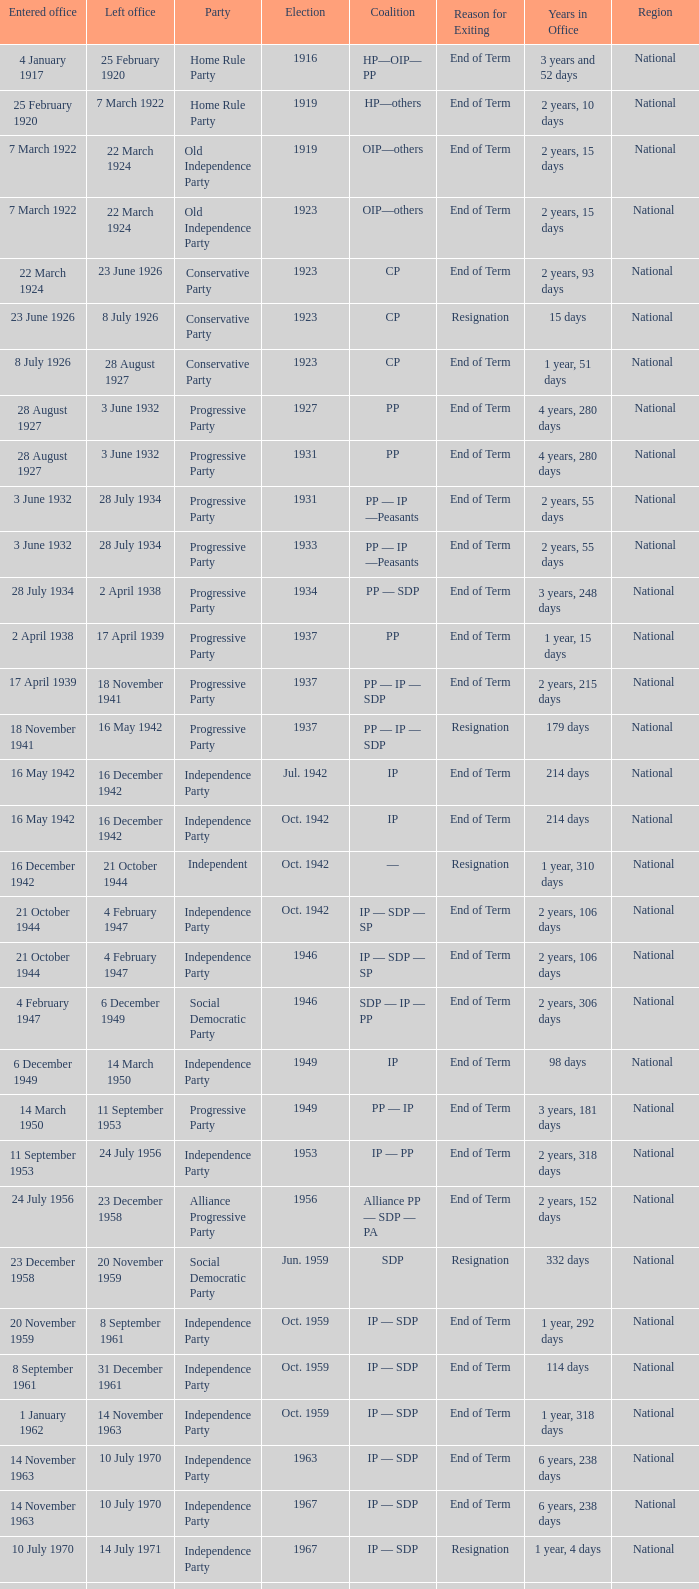When did the party elected in jun. 1959 enter office? 23 December 1958. 